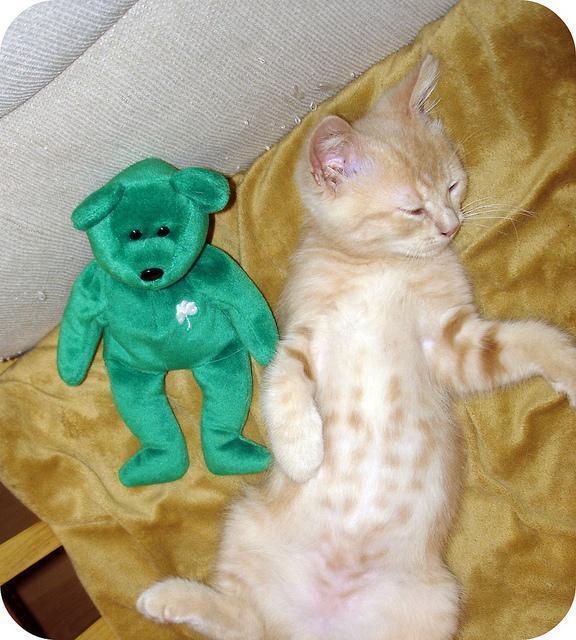Is "The couch is beneath the teddy bear." an appropriate description for the image?
Answer yes or no. Yes. 